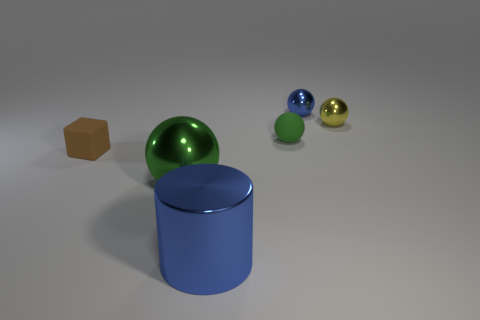Add 2 big spheres. How many objects exist? 8 Subtract all cylinders. How many objects are left? 5 Add 6 spheres. How many spheres are left? 10 Add 5 rubber spheres. How many rubber spheres exist? 6 Subtract 0 cyan blocks. How many objects are left? 6 Subtract all tiny metallic spheres. Subtract all cylinders. How many objects are left? 3 